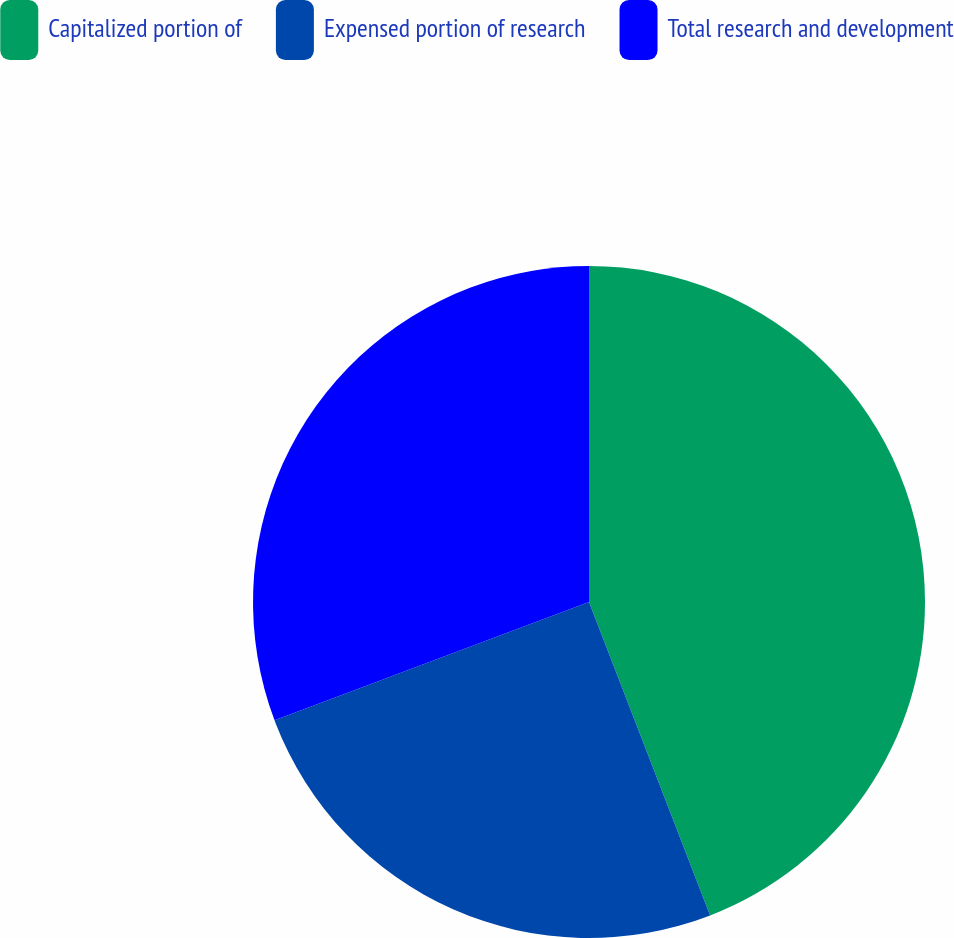Convert chart to OTSL. <chart><loc_0><loc_0><loc_500><loc_500><pie_chart><fcel>Capitalized portion of<fcel>Expensed portion of research<fcel>Total research and development<nl><fcel>44.13%<fcel>25.14%<fcel>30.73%<nl></chart> 